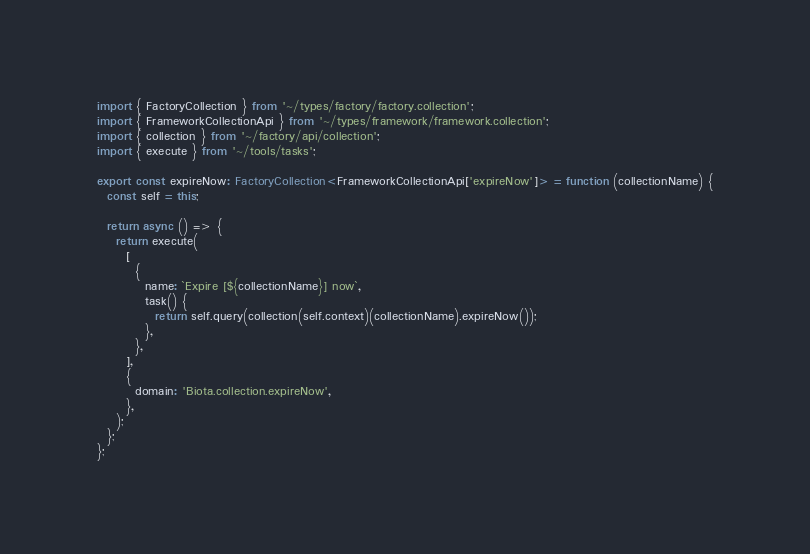<code> <loc_0><loc_0><loc_500><loc_500><_TypeScript_>import { FactoryCollection } from '~/types/factory/factory.collection';
import { FrameworkCollectionApi } from '~/types/framework/framework.collection';
import { collection } from '~/factory/api/collection';
import { execute } from '~/tools/tasks';

export const expireNow: FactoryCollection<FrameworkCollectionApi['expireNow']> = function (collectionName) {
  const self = this;

  return async () => {
    return execute(
      [
        {
          name: `Expire [${collectionName}] now`,
          task() {
            return self.query(collection(self.context)(collectionName).expireNow());
          },
        },
      ],
      {
        domain: 'Biota.collection.expireNow',
      },
    );
  };
};
</code> 